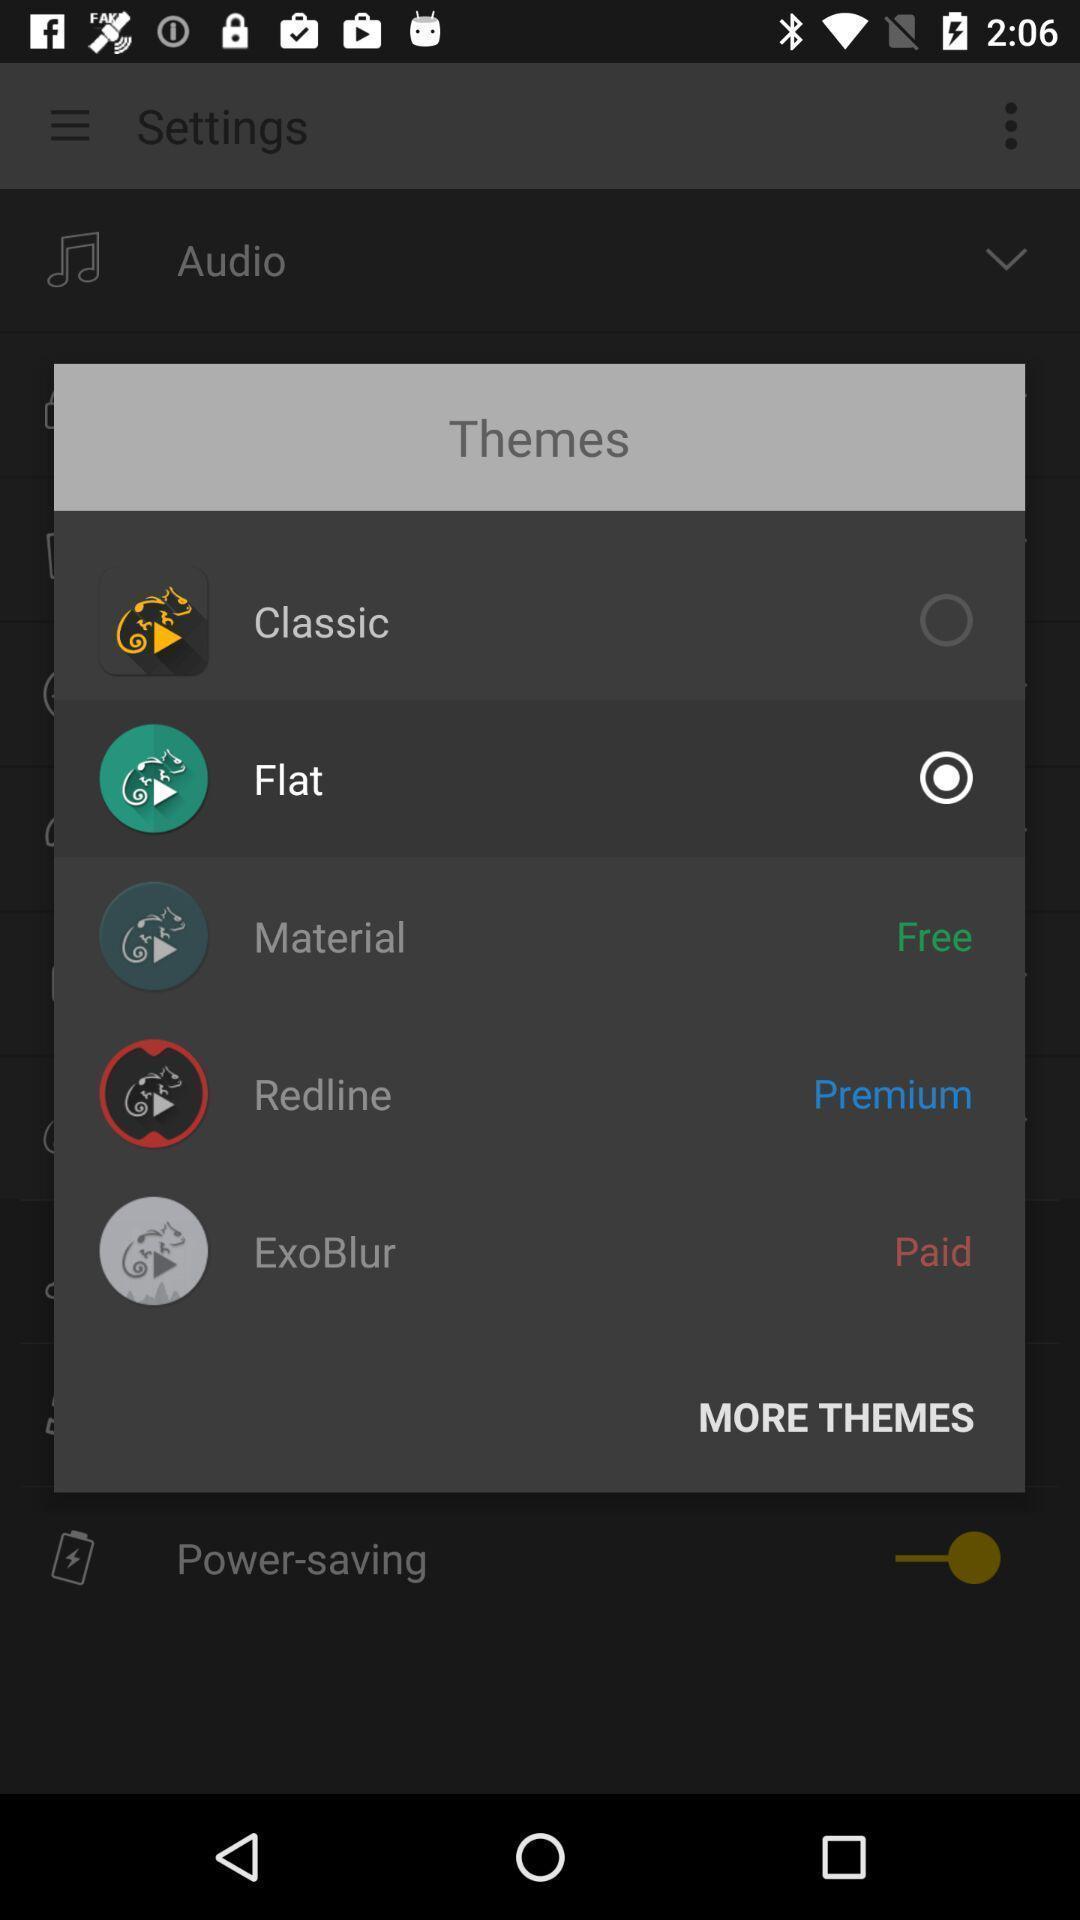What details can you identify in this image? Pop-up showing to select a theme. 